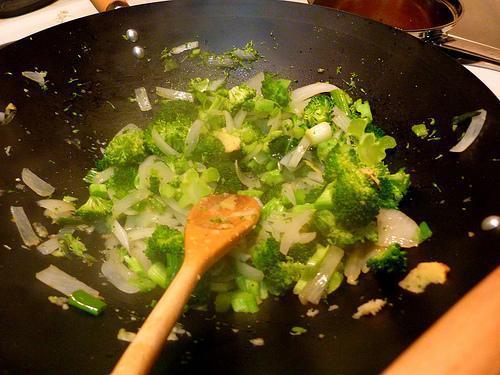How many spoons are there?
Give a very brief answer. 1. How many dinosaurs are in the picture?
Give a very brief answer. 0. How many people are eating donuts?
Give a very brief answer. 0. 